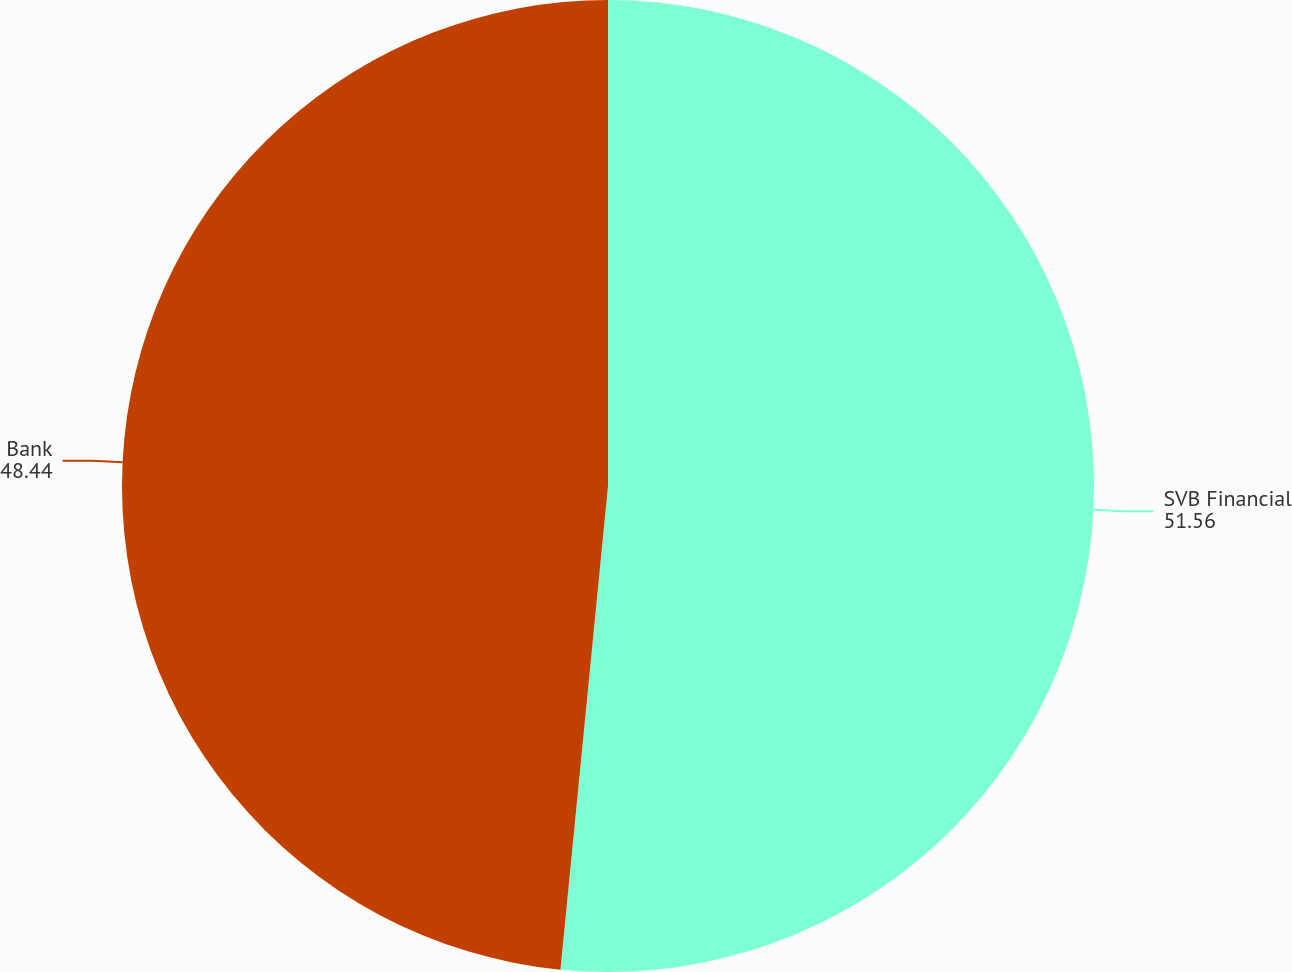<chart> <loc_0><loc_0><loc_500><loc_500><pie_chart><fcel>SVB Financial<fcel>Bank<nl><fcel>51.56%<fcel>48.44%<nl></chart> 